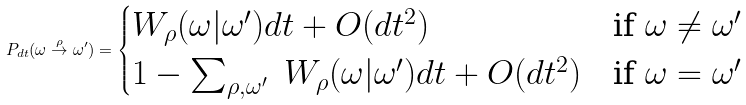Convert formula to latex. <formula><loc_0><loc_0><loc_500><loc_500>P _ { d t } ( \omega \overset { \rho } { \rightarrow } \omega ^ { \prime } ) = \begin{cases} W _ { \rho } ( \omega | \omega ^ { \prime } ) d t + O ( d t ^ { 2 } ) & \text {if $\omega \not= \omega^{\prime}$} \\ 1 - \sum _ { \rho , \omega ^ { \prime } } \ W _ { \rho } ( \omega | \omega ^ { \prime } ) d t + O ( d t ^ { 2 } ) & \text {if $\omega = \omega^{\prime}$} \end{cases}</formula> 